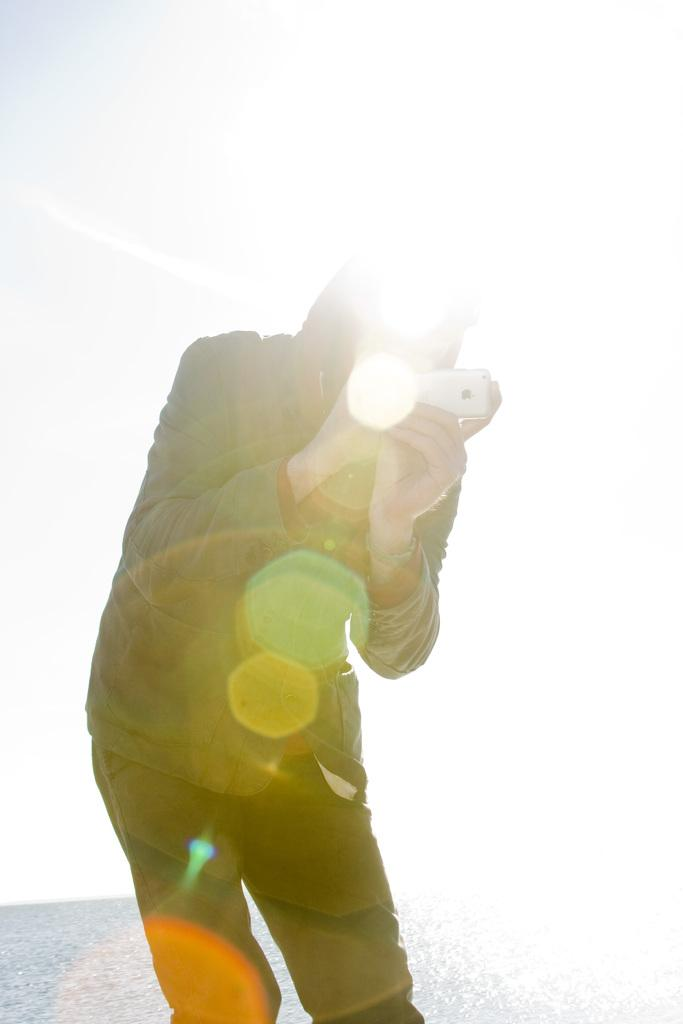What is the person in the image doing? The person is standing in the image. What object is the person holding in his hand? The person is holding a mobile phone in his hand. What can be seen in the background of the image? There is water visible in the image. What type of wax is being used to create the fog in the image? There is no wax or fog present in the image; it features a person standing with a mobile phone and water visible in the background. 